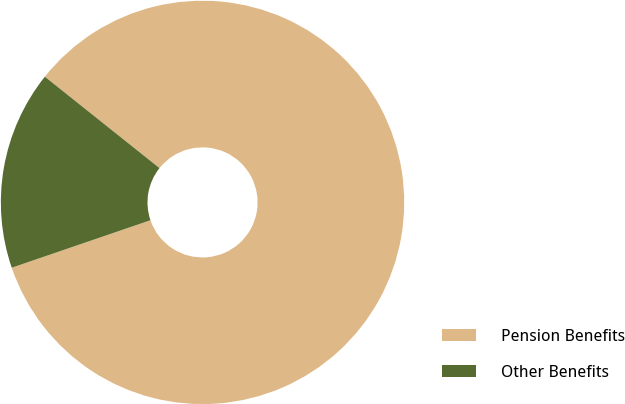Convert chart to OTSL. <chart><loc_0><loc_0><loc_500><loc_500><pie_chart><fcel>Pension Benefits<fcel>Other Benefits<nl><fcel>84.04%<fcel>15.96%<nl></chart> 